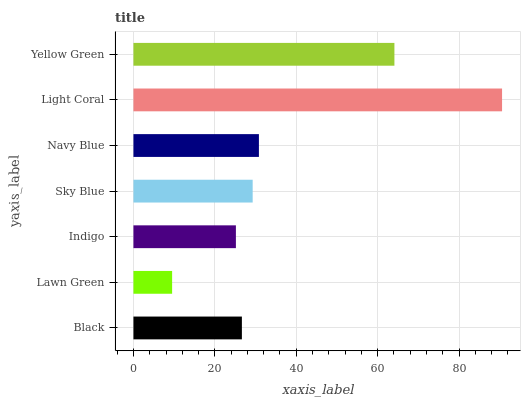Is Lawn Green the minimum?
Answer yes or no. Yes. Is Light Coral the maximum?
Answer yes or no. Yes. Is Indigo the minimum?
Answer yes or no. No. Is Indigo the maximum?
Answer yes or no. No. Is Indigo greater than Lawn Green?
Answer yes or no. Yes. Is Lawn Green less than Indigo?
Answer yes or no. Yes. Is Lawn Green greater than Indigo?
Answer yes or no. No. Is Indigo less than Lawn Green?
Answer yes or no. No. Is Sky Blue the high median?
Answer yes or no. Yes. Is Sky Blue the low median?
Answer yes or no. Yes. Is Light Coral the high median?
Answer yes or no. No. Is Indigo the low median?
Answer yes or no. No. 